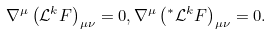Convert formula to latex. <formula><loc_0><loc_0><loc_500><loc_500>\nabla ^ { \mu } \left ( \mathcal { L } ^ { k } F \right ) _ { \mu \nu } = 0 , \nabla ^ { \mu } \left ( ^ { * } \mathcal { L } ^ { k } F \right ) _ { \mu \nu } = 0 .</formula> 